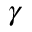Convert formula to latex. <formula><loc_0><loc_0><loc_500><loc_500>\gamma</formula> 